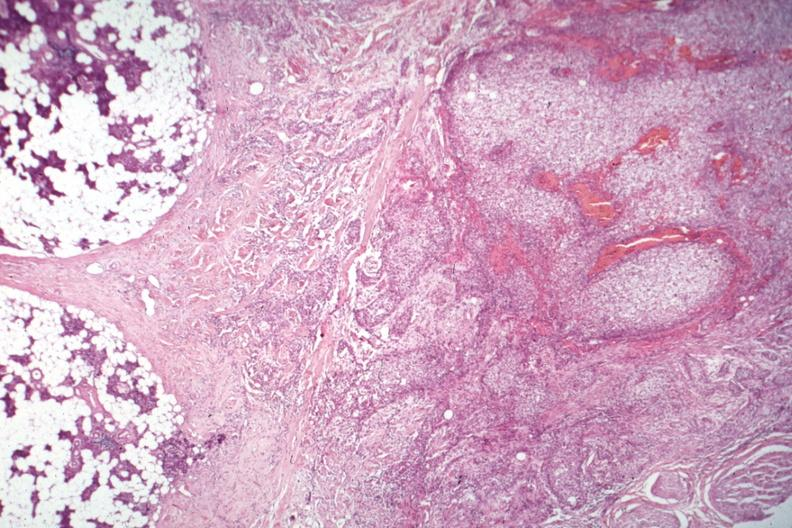does this image show nice photo of parotid on one side with tumor capsule and obvious invasive tumor?
Answer the question using a single word or phrase. Yes 